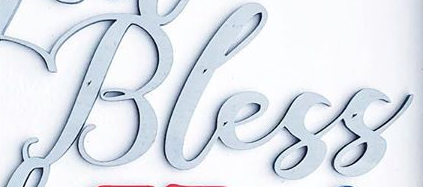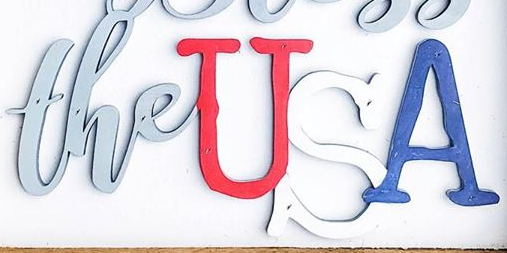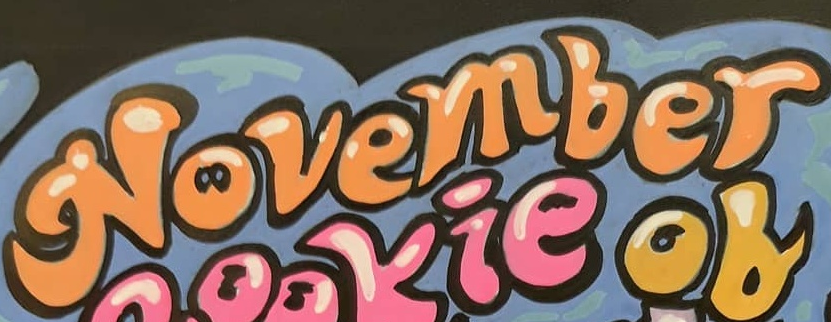What text appears in these images from left to right, separated by a semicolon? Bless; theUSA; November 